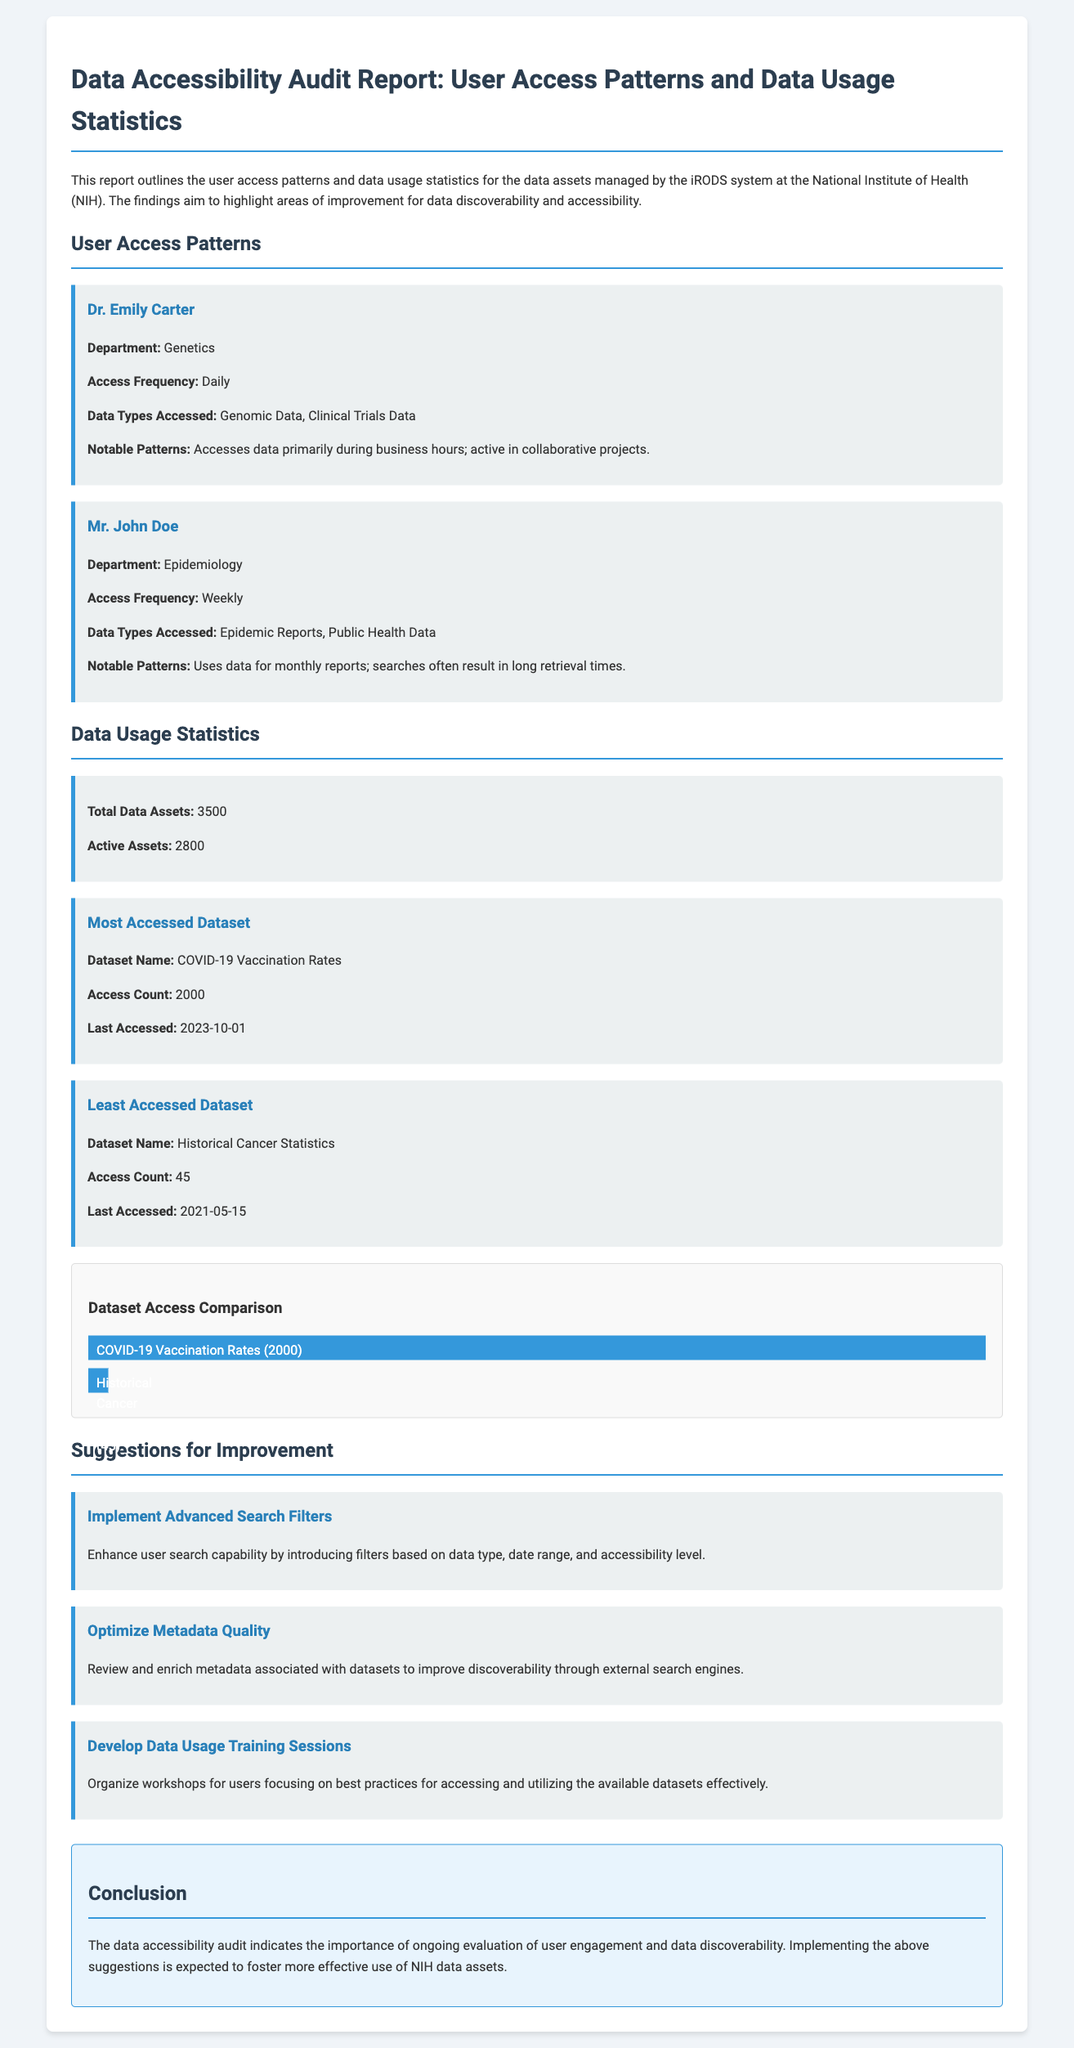What is the primary department of Dr. Emily Carter? The document states that Dr. Emily Carter is from the Genetics department.
Answer: Genetics How often does Mr. John Doe access data? According to the report, Mr. John Doe accesses data weekly.
Answer: Weekly What is the access count for the most accessed dataset? The document mentions that the most accessed dataset, COVID-19 Vaccination Rates, has an access count of 2000.
Answer: 2000 What are the suggested improvements for data discoverability? The report lists several suggestions, including implementing advanced search filters, optimizing metadata quality, and developing training sessions.
Answer: Advanced search filters When was the least accessed dataset last accessed? The document specifies that the least accessed dataset, Historical Cancer Statistics, was last accessed on May 15, 2021.
Answer: 2021-05-15 How many total data assets are mentioned in the report? The document states that there are a total of 3500 data assets.
Answer: 3500 What notable pattern is observed in Dr. Emily Carter's data access? The report highlights that Dr. Emily Carter predominantly accesses data during business hours and is active in collaborative projects.
Answer: Business hours What is one reason for Mr. John Doe's long retrieval times? The report indicates that Mr. John Doe's searches often result in long retrieval times due to the data he is accessing.
Answer: Long retrieval times 